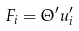Convert formula to latex. <formula><loc_0><loc_0><loc_500><loc_500>F _ { i } = \Theta ^ { \prime } u _ { i } ^ { \prime }</formula> 